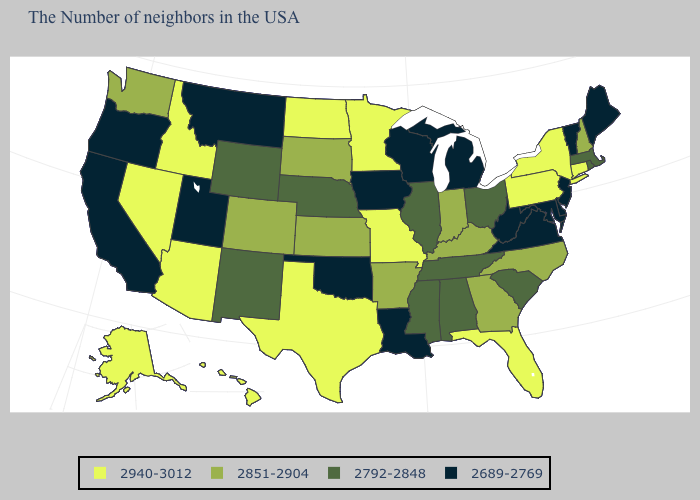What is the highest value in the USA?
Give a very brief answer. 2940-3012. What is the value of Minnesota?
Be succinct. 2940-3012. Among the states that border New Hampshire , does Massachusetts have the highest value?
Concise answer only. Yes. What is the lowest value in the USA?
Keep it brief. 2689-2769. Name the states that have a value in the range 2792-2848?
Quick response, please. Massachusetts, Rhode Island, South Carolina, Ohio, Alabama, Tennessee, Illinois, Mississippi, Nebraska, Wyoming, New Mexico. Which states have the highest value in the USA?
Concise answer only. Connecticut, New York, Pennsylvania, Florida, Missouri, Minnesota, Texas, North Dakota, Arizona, Idaho, Nevada, Alaska, Hawaii. What is the highest value in states that border Nevada?
Be succinct. 2940-3012. What is the value of Iowa?
Keep it brief. 2689-2769. How many symbols are there in the legend?
Write a very short answer. 4. Name the states that have a value in the range 2689-2769?
Concise answer only. Maine, Vermont, New Jersey, Delaware, Maryland, Virginia, West Virginia, Michigan, Wisconsin, Louisiana, Iowa, Oklahoma, Utah, Montana, California, Oregon. Among the states that border Massachusetts , which have the lowest value?
Be succinct. Vermont. Which states hav the highest value in the MidWest?
Be succinct. Missouri, Minnesota, North Dakota. Among the states that border North Carolina , which have the highest value?
Concise answer only. Georgia. What is the value of Arizona?
Give a very brief answer. 2940-3012. Name the states that have a value in the range 2940-3012?
Quick response, please. Connecticut, New York, Pennsylvania, Florida, Missouri, Minnesota, Texas, North Dakota, Arizona, Idaho, Nevada, Alaska, Hawaii. 